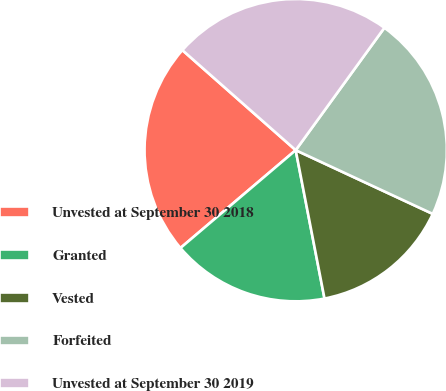Convert chart. <chart><loc_0><loc_0><loc_500><loc_500><pie_chart><fcel>Unvested at September 30 2018<fcel>Granted<fcel>Vested<fcel>Forfeited<fcel>Unvested at September 30 2019<nl><fcel>22.71%<fcel>16.85%<fcel>15.02%<fcel>21.95%<fcel>23.47%<nl></chart> 